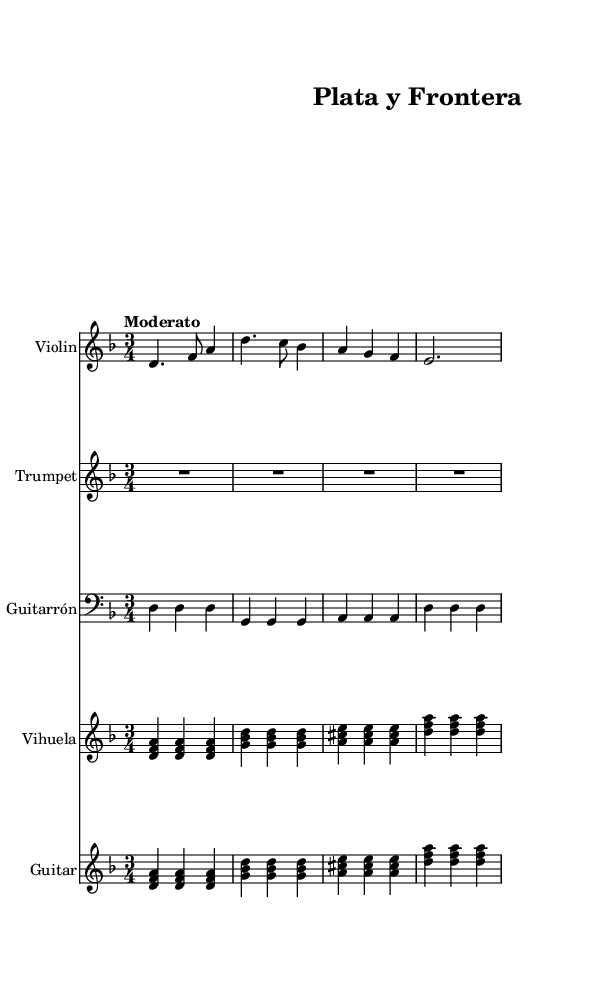What is the key signature of this music? The key signature is indicated at the beginning of the score, and it shows one flat, which corresponds to D minor.
Answer: D minor What is the time signature of this music? The time signature is shown following the key signature at the start of the score, indicating three beats per measure.
Answer: 3/4 What is the tempo marking for this piece? The tempo marking is noted in the score above the music and specifies the speed at which the piece should be played. In this case, it is set to "Moderato," which means moderate pace.
Answer: Moderato How many measures does the violin part have? By counting the individual measures indicated in the violin staff, we can see that there are four measures in total.
Answer: 4 Which instruments are included in this arrangement? The instruments are listed at the beginning of each staff, showing that there are five instruments: Violin, Trumpet, Guitarrón, Vihuela, and Guitar.
Answer: Violin, Trumpet, Guitarrón, Vihuela, Guitar What is the lyric's first line in English? The lyrics are given in Spanish and are displayed directly below the corresponding music notes. The first line translates to "In the mines of Zacatecas."
Answer: In the mines of Zacatecas 